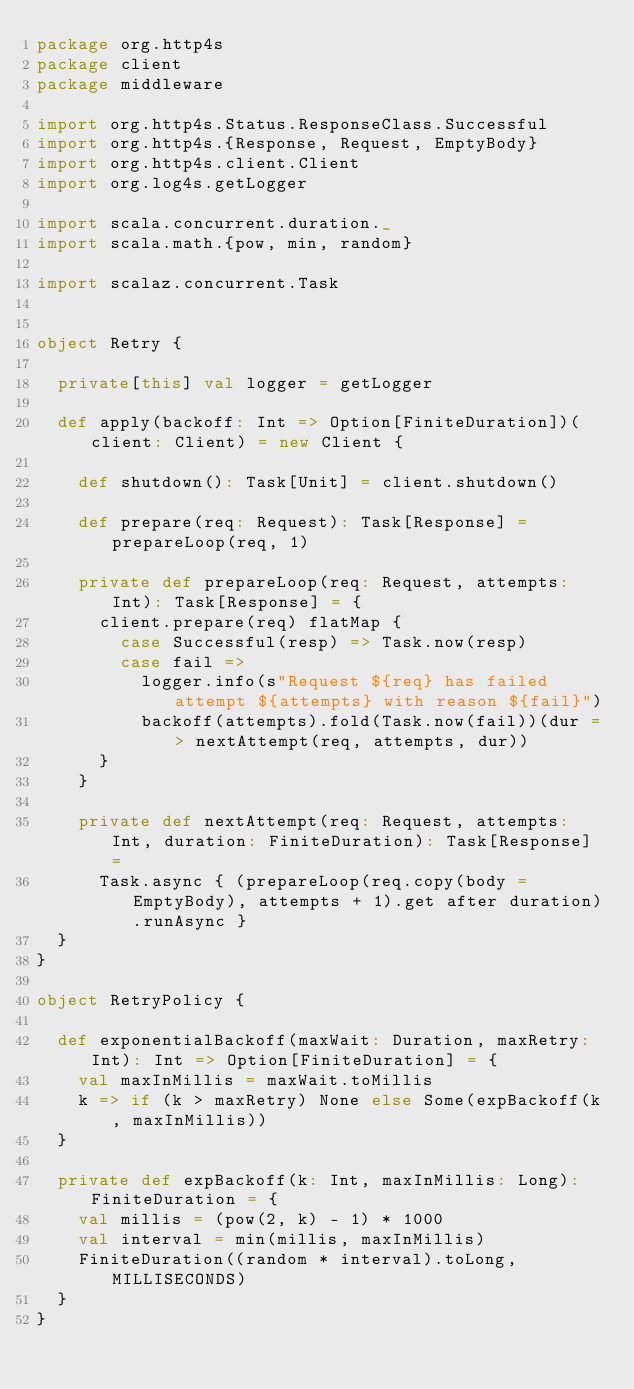<code> <loc_0><loc_0><loc_500><loc_500><_Scala_>package org.http4s
package client
package middleware

import org.http4s.Status.ResponseClass.Successful
import org.http4s.{Response, Request, EmptyBody}
import org.http4s.client.Client
import org.log4s.getLogger

import scala.concurrent.duration._
import scala.math.{pow, min, random}

import scalaz.concurrent.Task


object Retry {
 
  private[this] val logger = getLogger

  def apply(backoff: Int => Option[FiniteDuration])(client: Client) = new Client {

    def shutdown(): Task[Unit] = client.shutdown()

    def prepare(req: Request): Task[Response] = prepareLoop(req, 1)

    private def prepareLoop(req: Request, attempts: Int): Task[Response] = {
      client.prepare(req) flatMap {
        case Successful(resp) => Task.now(resp)
        case fail => 
          logger.info(s"Request ${req} has failed attempt ${attempts} with reason ${fail}")
          backoff(attempts).fold(Task.now(fail))(dur => nextAttempt(req, attempts, dur))
      }
    }

    private def nextAttempt(req: Request, attempts: Int, duration: FiniteDuration): Task[Response] =
      Task.async { (prepareLoop(req.copy(body = EmptyBody), attempts + 1).get after duration).runAsync }
  }
}

object RetryPolicy {

  def exponentialBackoff(maxWait: Duration, maxRetry: Int): Int => Option[FiniteDuration] = {
    val maxInMillis = maxWait.toMillis
    k => if (k > maxRetry) None else Some(expBackoff(k, maxInMillis))
  }

  private def expBackoff(k: Int, maxInMillis: Long): FiniteDuration = {
    val millis = (pow(2, k) - 1) * 1000
    val interval = min(millis, maxInMillis)
    FiniteDuration((random * interval).toLong, MILLISECONDS)
  }
}
</code> 